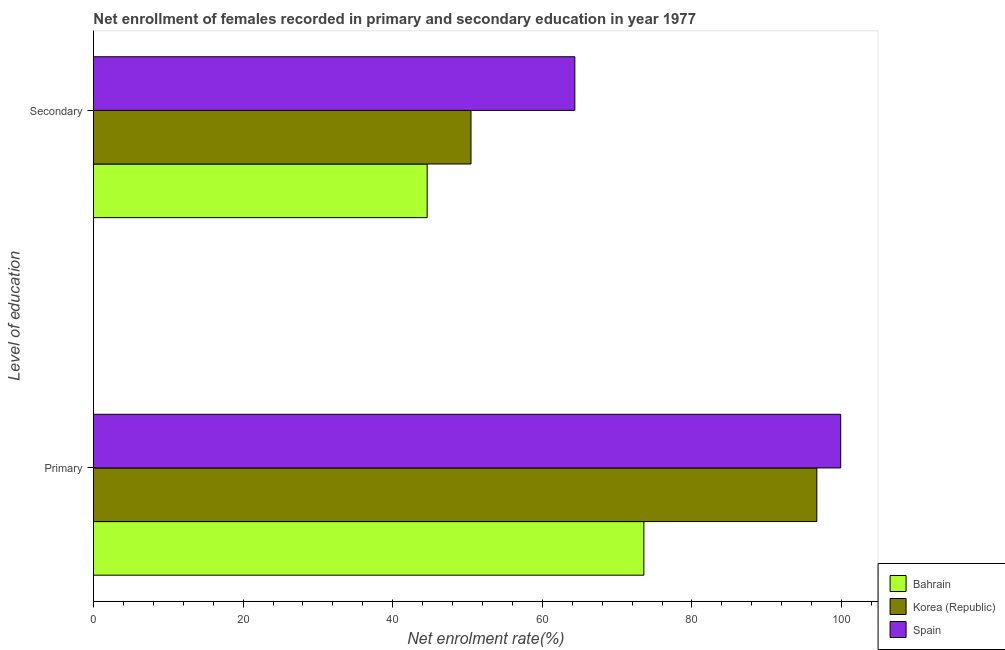How many different coloured bars are there?
Offer a very short reply. 3. What is the label of the 2nd group of bars from the top?
Your answer should be compact. Primary. What is the enrollment rate in primary education in Spain?
Your response must be concise. 99.88. Across all countries, what is the maximum enrollment rate in secondary education?
Ensure brevity in your answer.  64.34. Across all countries, what is the minimum enrollment rate in primary education?
Keep it short and to the point. 73.57. In which country was the enrollment rate in secondary education maximum?
Provide a short and direct response. Spain. In which country was the enrollment rate in primary education minimum?
Ensure brevity in your answer.  Bahrain. What is the total enrollment rate in secondary education in the graph?
Your answer should be very brief. 159.41. What is the difference between the enrollment rate in primary education in Spain and that in Korea (Republic)?
Offer a very short reply. 3.19. What is the difference between the enrollment rate in primary education in Bahrain and the enrollment rate in secondary education in Korea (Republic)?
Provide a succinct answer. 23.11. What is the average enrollment rate in secondary education per country?
Your response must be concise. 53.14. What is the difference between the enrollment rate in secondary education and enrollment rate in primary education in Bahrain?
Your answer should be compact. -28.97. What is the ratio of the enrollment rate in primary education in Korea (Republic) to that in Spain?
Keep it short and to the point. 0.97. Is the enrollment rate in primary education in Spain less than that in Korea (Republic)?
Make the answer very short. No. In how many countries, is the enrollment rate in secondary education greater than the average enrollment rate in secondary education taken over all countries?
Your answer should be very brief. 1. What does the 1st bar from the top in Primary represents?
Ensure brevity in your answer.  Spain. What does the 1st bar from the bottom in Primary represents?
Provide a short and direct response. Bahrain. Are all the bars in the graph horizontal?
Make the answer very short. Yes. How many countries are there in the graph?
Ensure brevity in your answer.  3. Does the graph contain any zero values?
Offer a very short reply. No. Does the graph contain grids?
Keep it short and to the point. No. How many legend labels are there?
Offer a very short reply. 3. How are the legend labels stacked?
Keep it short and to the point. Vertical. What is the title of the graph?
Make the answer very short. Net enrollment of females recorded in primary and secondary education in year 1977. Does "Caribbean small states" appear as one of the legend labels in the graph?
Give a very brief answer. No. What is the label or title of the X-axis?
Your response must be concise. Net enrolment rate(%). What is the label or title of the Y-axis?
Offer a terse response. Level of education. What is the Net enrolment rate(%) of Bahrain in Primary?
Make the answer very short. 73.57. What is the Net enrolment rate(%) in Korea (Republic) in Primary?
Make the answer very short. 96.69. What is the Net enrolment rate(%) in Spain in Primary?
Provide a short and direct response. 99.88. What is the Net enrolment rate(%) of Bahrain in Secondary?
Offer a very short reply. 44.6. What is the Net enrolment rate(%) of Korea (Republic) in Secondary?
Keep it short and to the point. 50.46. What is the Net enrolment rate(%) of Spain in Secondary?
Your answer should be compact. 64.34. Across all Level of education, what is the maximum Net enrolment rate(%) in Bahrain?
Ensure brevity in your answer.  73.57. Across all Level of education, what is the maximum Net enrolment rate(%) of Korea (Republic)?
Make the answer very short. 96.69. Across all Level of education, what is the maximum Net enrolment rate(%) of Spain?
Keep it short and to the point. 99.88. Across all Level of education, what is the minimum Net enrolment rate(%) of Bahrain?
Ensure brevity in your answer.  44.6. Across all Level of education, what is the minimum Net enrolment rate(%) of Korea (Republic)?
Your response must be concise. 50.46. Across all Level of education, what is the minimum Net enrolment rate(%) of Spain?
Provide a succinct answer. 64.34. What is the total Net enrolment rate(%) in Bahrain in the graph?
Your response must be concise. 118.17. What is the total Net enrolment rate(%) in Korea (Republic) in the graph?
Ensure brevity in your answer.  147.15. What is the total Net enrolment rate(%) in Spain in the graph?
Give a very brief answer. 164.22. What is the difference between the Net enrolment rate(%) in Bahrain in Primary and that in Secondary?
Give a very brief answer. 28.97. What is the difference between the Net enrolment rate(%) in Korea (Republic) in Primary and that in Secondary?
Make the answer very short. 46.22. What is the difference between the Net enrolment rate(%) of Spain in Primary and that in Secondary?
Give a very brief answer. 35.54. What is the difference between the Net enrolment rate(%) in Bahrain in Primary and the Net enrolment rate(%) in Korea (Republic) in Secondary?
Provide a short and direct response. 23.11. What is the difference between the Net enrolment rate(%) of Bahrain in Primary and the Net enrolment rate(%) of Spain in Secondary?
Ensure brevity in your answer.  9.23. What is the difference between the Net enrolment rate(%) of Korea (Republic) in Primary and the Net enrolment rate(%) of Spain in Secondary?
Give a very brief answer. 32.34. What is the average Net enrolment rate(%) of Bahrain per Level of education?
Offer a very short reply. 59.09. What is the average Net enrolment rate(%) of Korea (Republic) per Level of education?
Your response must be concise. 73.57. What is the average Net enrolment rate(%) of Spain per Level of education?
Your answer should be compact. 82.11. What is the difference between the Net enrolment rate(%) in Bahrain and Net enrolment rate(%) in Korea (Republic) in Primary?
Your answer should be very brief. -23.12. What is the difference between the Net enrolment rate(%) of Bahrain and Net enrolment rate(%) of Spain in Primary?
Provide a short and direct response. -26.31. What is the difference between the Net enrolment rate(%) of Korea (Republic) and Net enrolment rate(%) of Spain in Primary?
Offer a terse response. -3.19. What is the difference between the Net enrolment rate(%) in Bahrain and Net enrolment rate(%) in Korea (Republic) in Secondary?
Offer a terse response. -5.86. What is the difference between the Net enrolment rate(%) of Bahrain and Net enrolment rate(%) of Spain in Secondary?
Provide a short and direct response. -19.74. What is the difference between the Net enrolment rate(%) in Korea (Republic) and Net enrolment rate(%) in Spain in Secondary?
Offer a very short reply. -13.88. What is the ratio of the Net enrolment rate(%) of Bahrain in Primary to that in Secondary?
Your answer should be very brief. 1.65. What is the ratio of the Net enrolment rate(%) of Korea (Republic) in Primary to that in Secondary?
Keep it short and to the point. 1.92. What is the ratio of the Net enrolment rate(%) in Spain in Primary to that in Secondary?
Offer a very short reply. 1.55. What is the difference between the highest and the second highest Net enrolment rate(%) of Bahrain?
Keep it short and to the point. 28.97. What is the difference between the highest and the second highest Net enrolment rate(%) in Korea (Republic)?
Ensure brevity in your answer.  46.22. What is the difference between the highest and the second highest Net enrolment rate(%) in Spain?
Offer a very short reply. 35.54. What is the difference between the highest and the lowest Net enrolment rate(%) in Bahrain?
Your answer should be very brief. 28.97. What is the difference between the highest and the lowest Net enrolment rate(%) in Korea (Republic)?
Offer a very short reply. 46.22. What is the difference between the highest and the lowest Net enrolment rate(%) of Spain?
Your answer should be very brief. 35.54. 